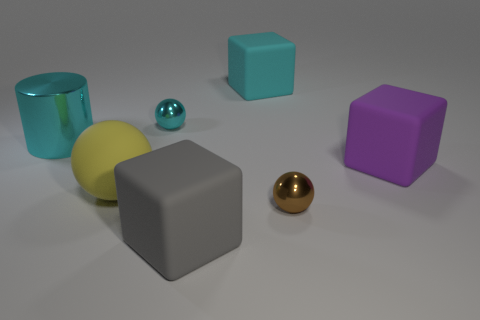If these objects were part of a game, how could they be used? If these objects were part of a game, the different shapes and colors could correspond to different values or properties. For example, the balls might represent different points, with the matte yellow one being standard and the metallic balls providing bonus points. The cubes could serve as obstacles or bases to capture and hold, the colors indicating ownership or type—blue for water, purple for magic, and grey as a neutral territory. The cylindrical shape of the blue object could be a container or a 'portal' that changes the game dynamics when interacted with. 